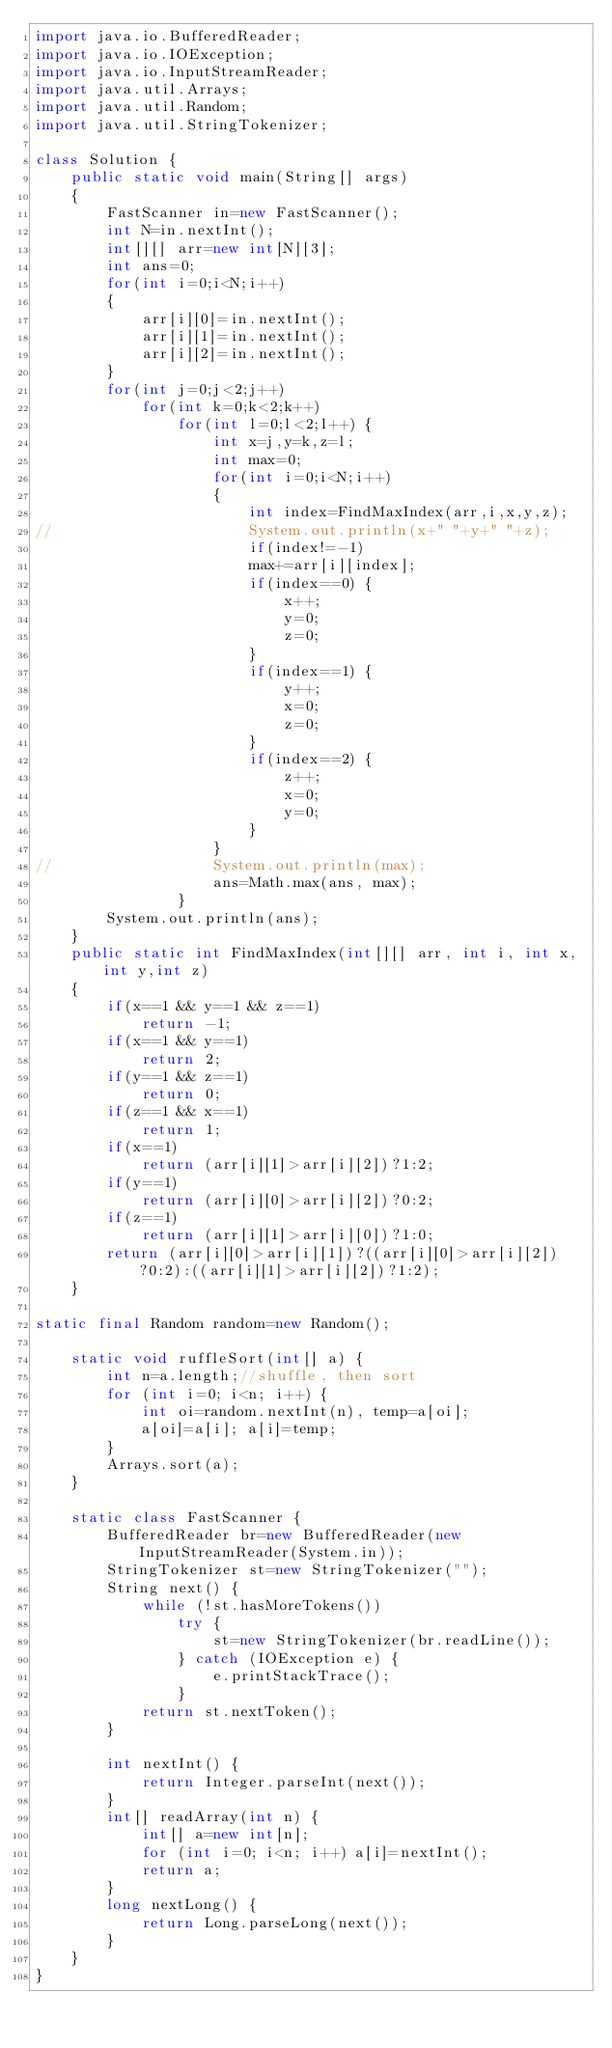<code> <loc_0><loc_0><loc_500><loc_500><_Java_>import java.io.BufferedReader;
import java.io.IOException;
import java.io.InputStreamReader;
import java.util.Arrays;
import java.util.Random;
import java.util.StringTokenizer;

class Solution {
	public static void main(String[] args)
	{
		FastScanner in=new FastScanner();
		int N=in.nextInt();
		int[][] arr=new int[N][3];
		int ans=0;
		for(int i=0;i<N;i++)
		{
			arr[i][0]=in.nextInt();
			arr[i][1]=in.nextInt();
			arr[i][2]=in.nextInt();		
		}
		for(int j=0;j<2;j++)
			for(int k=0;k<2;k++)
				for(int l=0;l<2;l++) {
					int x=j,y=k,z=l;
					int max=0;
					for(int i=0;i<N;i++)
					{
						int index=FindMaxIndex(arr,i,x,y,z);
//						System.out.println(x+" "+y+" "+z);
						if(index!=-1)
						max+=arr[i][index];
						if(index==0) {
							x++;
							y=0;
							z=0;
						}
						if(index==1) {
							y++;
							x=0;
							z=0;
						}
						if(index==2) {
							z++;
							x=0;
							y=0;
						}
					}
//					System.out.println(max);
					ans=Math.max(ans, max);
				}
		System.out.println(ans);
	}
	public static int FindMaxIndex(int[][] arr, int i, int x,int y,int z)
	{
		if(x==1 && y==1 && z==1)
			return -1;
		if(x==1 && y==1)
			return 2;
		if(y==1 && z==1)
			return 0;
		if(z==1 && x==1)
			return 1;
		if(x==1)
			return (arr[i][1]>arr[i][2])?1:2;
		if(y==1)
			return (arr[i][0]>arr[i][2])?0:2;
		if(z==1)
			return (arr[i][1]>arr[i][0])?1:0;
		return (arr[i][0]>arr[i][1])?((arr[i][0]>arr[i][2])?0:2):((arr[i][1]>arr[i][2])?1:2);
	}
	
static final Random random=new Random();
	
	static void ruffleSort(int[] a) {
		int n=a.length;//shuffle, then sort 
		for (int i=0; i<n; i++) {
			int oi=random.nextInt(n), temp=a[oi];
			a[oi]=a[i]; a[i]=temp;
		}
		Arrays.sort(a);
	}
	
	static class FastScanner {
		BufferedReader br=new BufferedReader(new InputStreamReader(System.in));
		StringTokenizer st=new StringTokenizer("");
		String next() {
			while (!st.hasMoreTokens())
				try {
					st=new StringTokenizer(br.readLine());
				} catch (IOException e) {
					e.printStackTrace();
				}
			return st.nextToken();
		}
		
		int nextInt() {
			return Integer.parseInt(next());
		}
		int[] readArray(int n) {
			int[] a=new int[n];
			for (int i=0; i<n; i++) a[i]=nextInt();
			return a;
		}
		long nextLong() {
			return Long.parseLong(next());
		}
	}
}
</code> 